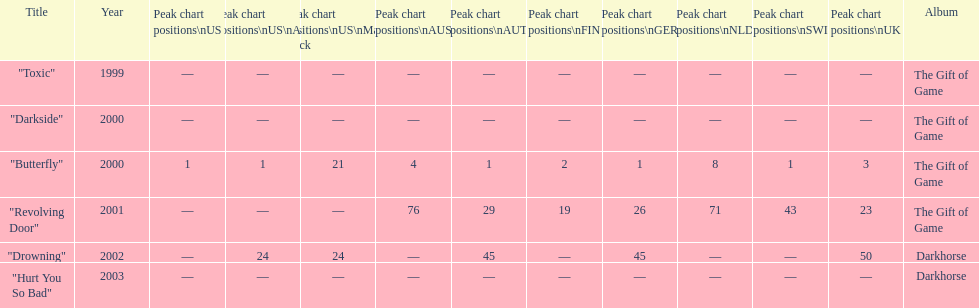What is the count of times the single "butterfly" was ranked as number 1 on the chart? 5. Give me the full table as a dictionary. {'header': ['Title', 'Year', 'Peak chart positions\\nUS', 'Peak chart positions\\nUS\\nAlt.', 'Peak chart positions\\nUS\\nMain. Rock', 'Peak chart positions\\nAUS', 'Peak chart positions\\nAUT', 'Peak chart positions\\nFIN', 'Peak chart positions\\nGER', 'Peak chart positions\\nNLD', 'Peak chart positions\\nSWI', 'Peak chart positions\\nUK', 'Album'], 'rows': [['"Toxic"', '1999', '—', '—', '—', '—', '—', '—', '—', '—', '—', '—', 'The Gift of Game'], ['"Darkside"', '2000', '—', '—', '—', '—', '—', '—', '—', '—', '—', '—', 'The Gift of Game'], ['"Butterfly"', '2000', '1', '1', '21', '4', '1', '2', '1', '8', '1', '3', 'The Gift of Game'], ['"Revolving Door"', '2001', '—', '—', '—', '76', '29', '19', '26', '71', '43', '23', 'The Gift of Game'], ['"Drowning"', '2002', '—', '24', '24', '—', '45', '—', '45', '—', '—', '50', 'Darkhorse'], ['"Hurt You So Bad"', '2003', '—', '—', '—', '—', '—', '—', '—', '—', '—', '—', 'Darkhorse']]} 